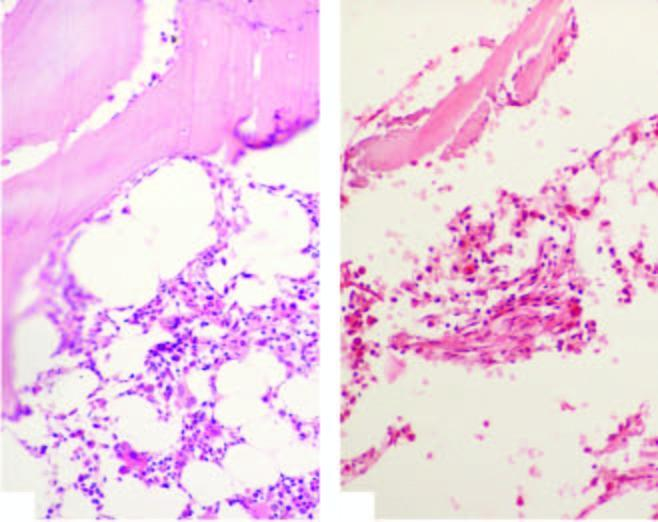re there scanty foci of cellular components composed chiefly of lymphoid cells?
Answer the question using a single word or phrase. Yes 